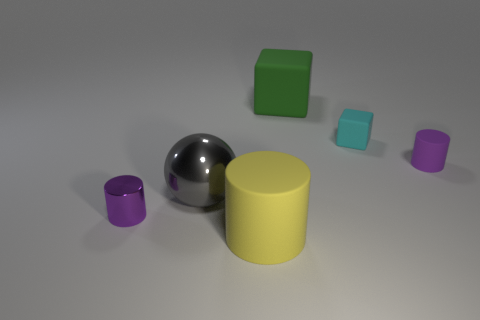What number of rubber things have the same color as the small shiny thing?
Provide a short and direct response. 1. What material is the green cube?
Provide a succinct answer. Rubber. There is a cylinder that is on the left side of the ball; does it have the same color as the tiny rubber cylinder?
Your answer should be very brief. Yes. Is there anything else that has the same shape as the cyan rubber object?
Your response must be concise. Yes. There is another big thing that is the same shape as the cyan matte thing; what is its color?
Offer a very short reply. Green. What is the small purple object on the right side of the big green object made of?
Give a very brief answer. Rubber. The big metallic ball is what color?
Offer a very short reply. Gray. There is a purple object to the right of the green matte object; does it have the same size as the big matte block?
Provide a short and direct response. No. What is the material of the purple cylinder that is to the left of the tiny purple thing that is right of the small cylinder that is left of the yellow object?
Offer a very short reply. Metal. Do the tiny cylinder that is to the left of the tiny cyan block and the cube on the left side of the tiny cyan thing have the same color?
Offer a terse response. No. 